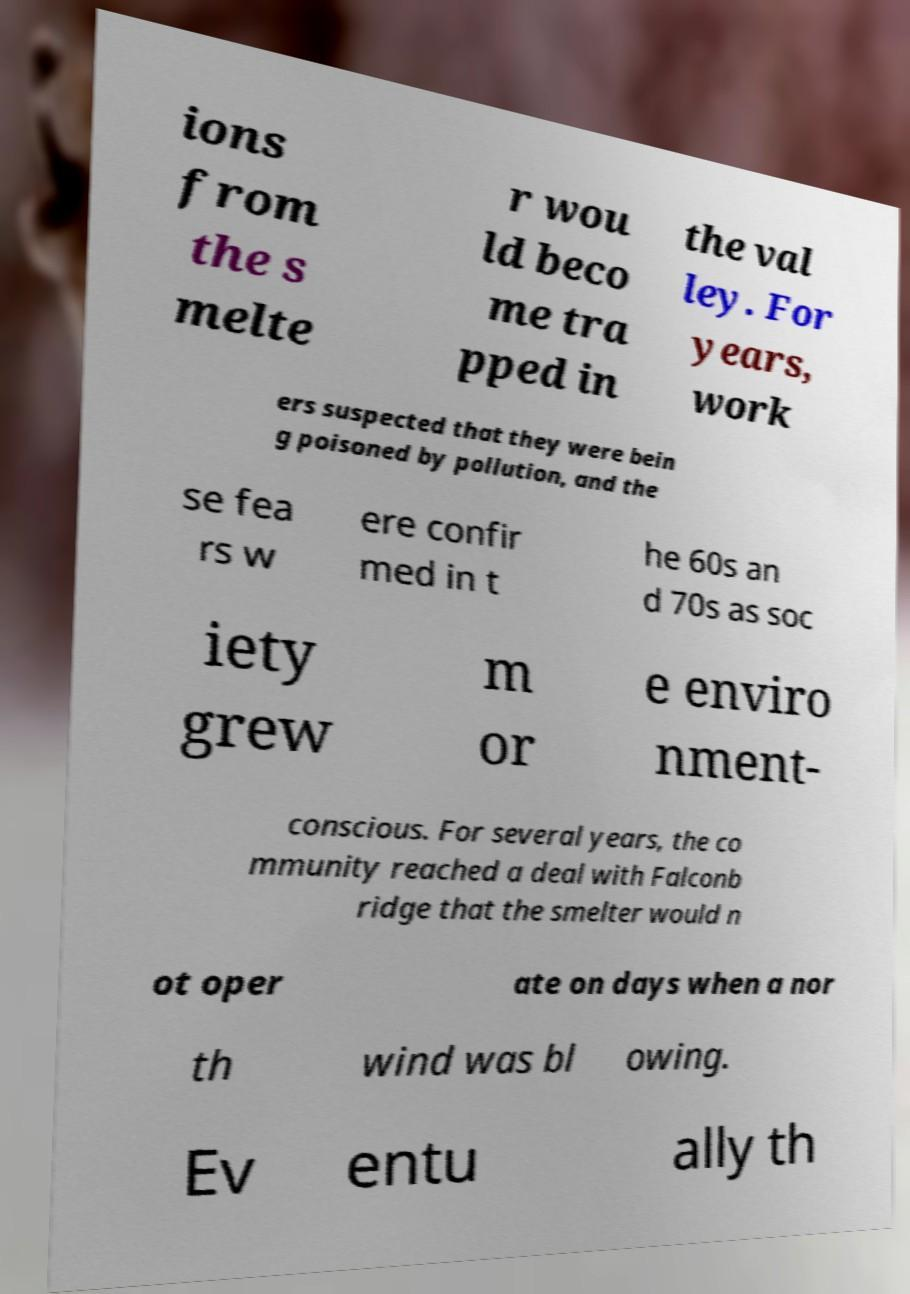For documentation purposes, I need the text within this image transcribed. Could you provide that? ions from the s melte r wou ld beco me tra pped in the val ley. For years, work ers suspected that they were bein g poisoned by pollution, and the se fea rs w ere confir med in t he 60s an d 70s as soc iety grew m or e enviro nment- conscious. For several years, the co mmunity reached a deal with Falconb ridge that the smelter would n ot oper ate on days when a nor th wind was bl owing. Ev entu ally th 